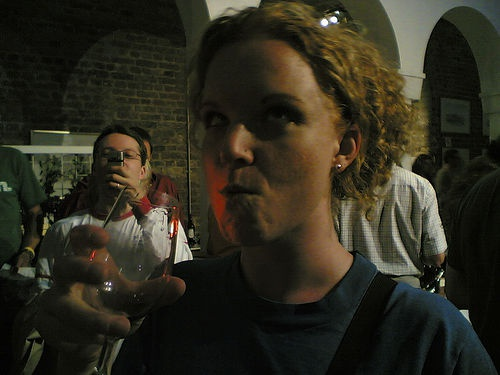Describe the objects in this image and their specific colors. I can see people in black, olive, maroon, and gray tones, people in black, gray, and darkgray tones, people in black, gray, darkgray, and darkgreen tones, wine glass in black, maroon, and gray tones, and people in black, gray, and darkgreen tones in this image. 